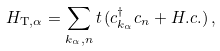<formula> <loc_0><loc_0><loc_500><loc_500>H _ { \mathrm T , \alpha } = \sum _ { k _ { \alpha } , n } t \, ( c ^ { \dagger } _ { k _ { \alpha } } c _ { n } + H . c . ) \, ,</formula> 